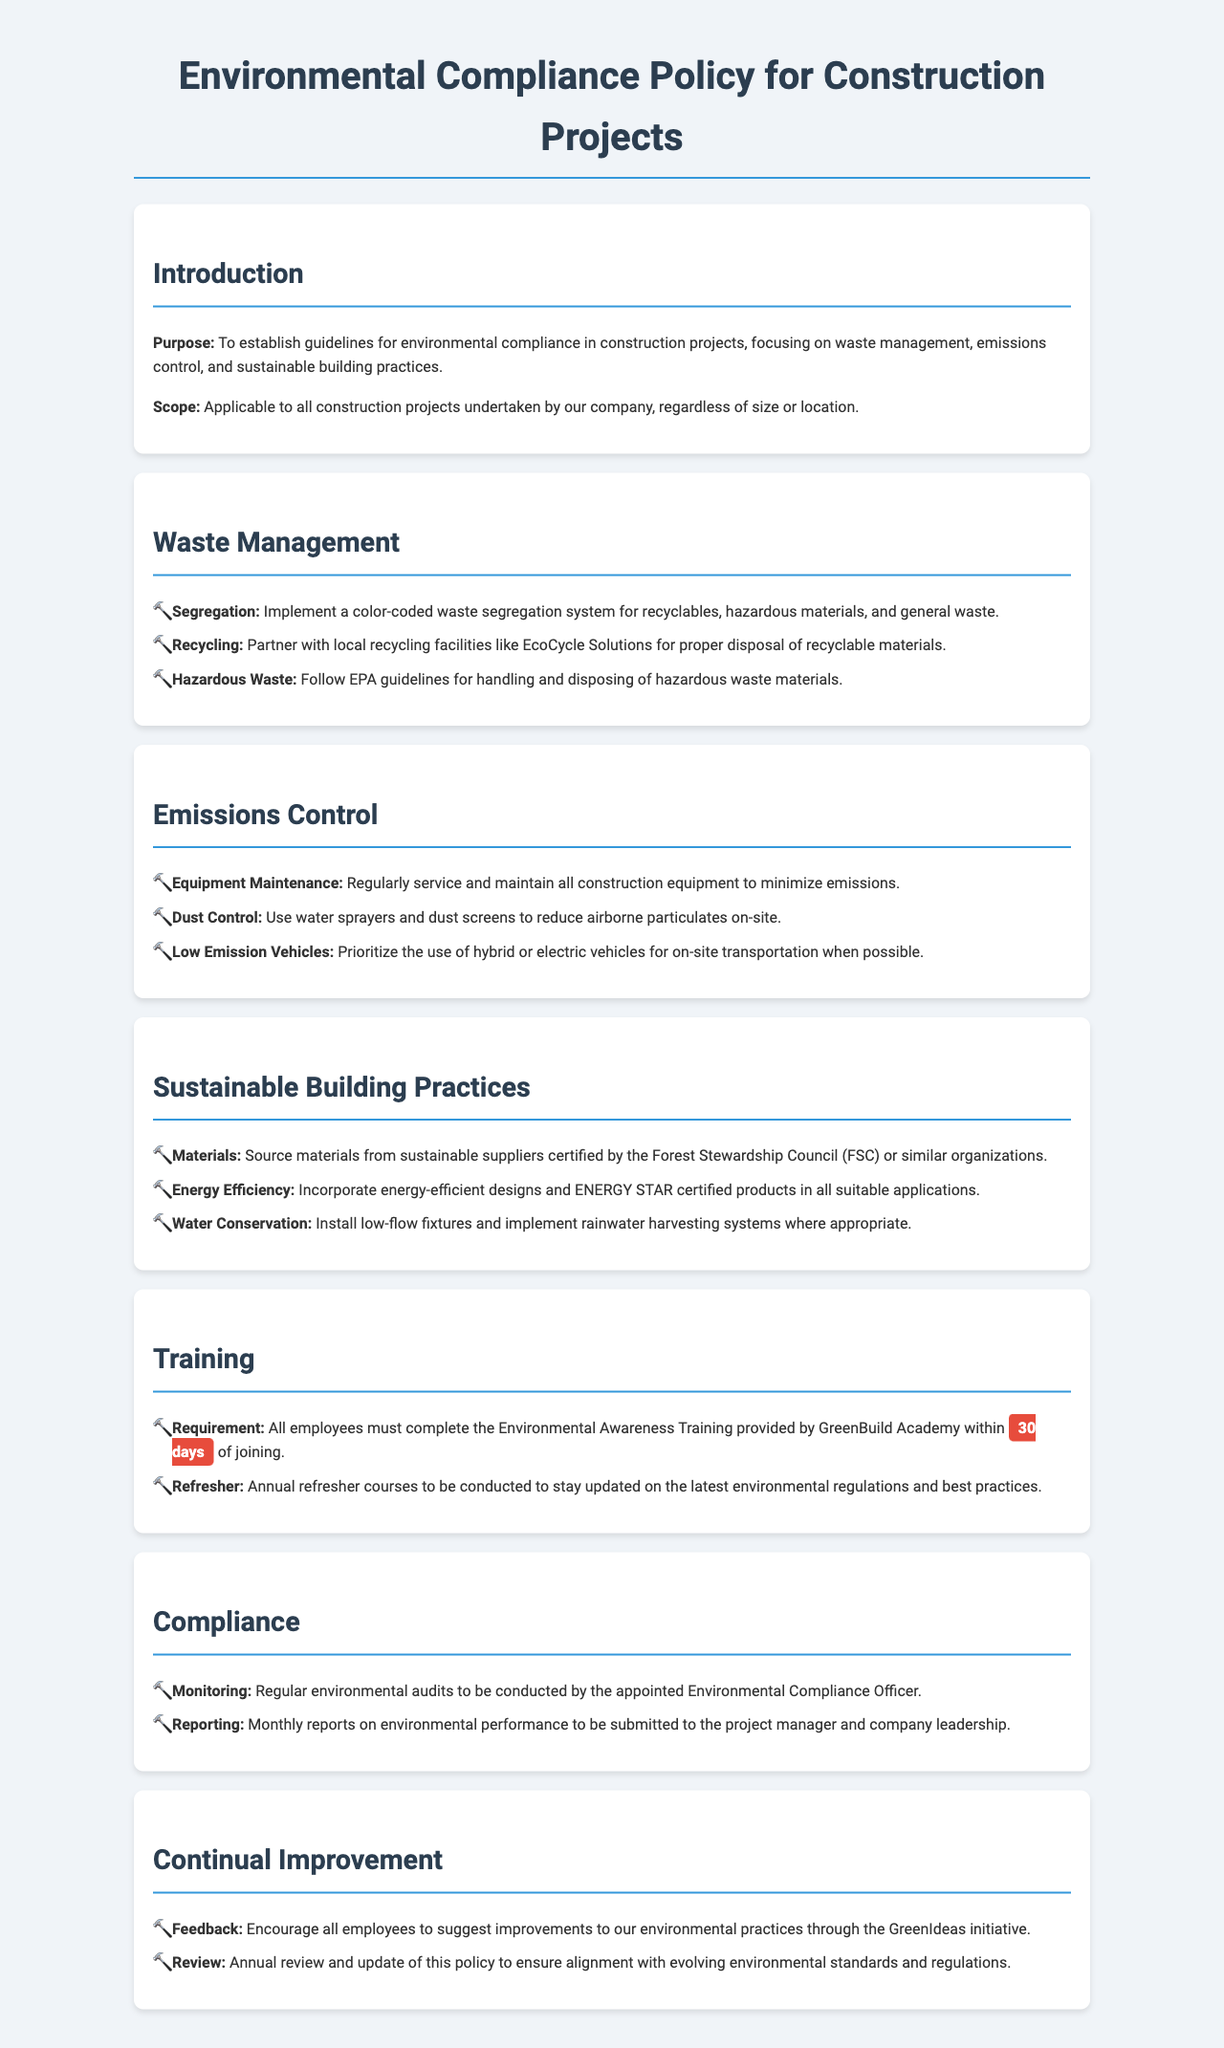what is the purpose of the document? The purpose is to establish guidelines for environmental compliance in construction projects, focusing on waste management, emissions control, and sustainable building practices.
Answer: To establish guidelines for environmental compliance what is the color-coding system used for? The color-coded waste segregation system is implemented for recyclables, hazardous materials, and general waste.
Answer: Waste segregation who do we partner with for recycling? The document mentions partnering with local recycling facilities for proper disposal of recyclable materials, specifically EcoCycle Solutions.
Answer: EcoCycle Solutions what is the timeframe for completing the Environmental Awareness Training? All employees must complete the Environmental Awareness Training within 30 days of joining.
Answer: 30 days what products should we incorporate for energy efficiency? The document specifies incorporating ENERGY STAR certified products in all suitable applications for energy efficiency.
Answer: ENERGY STAR certified products how often should refresher courses be conducted? Annual refresher courses should be conducted to stay updated on the latest environmental regulations and best practices.
Answer: Annual who is responsible for conducting regular environmental audits? The appointed Environmental Compliance Officer is responsible for conducting regular environmental audits.
Answer: Environmental Compliance Officer what initiative encourages employee feedback on environmental practices? The GreenIdeas initiative encourages all employees to suggest improvements to our environmental practices.
Answer: GreenIdeas how often is the environmental policy reviewed? The policy is reviewed and updated annually to ensure alignment with evolving environmental standards and regulations.
Answer: Annually 